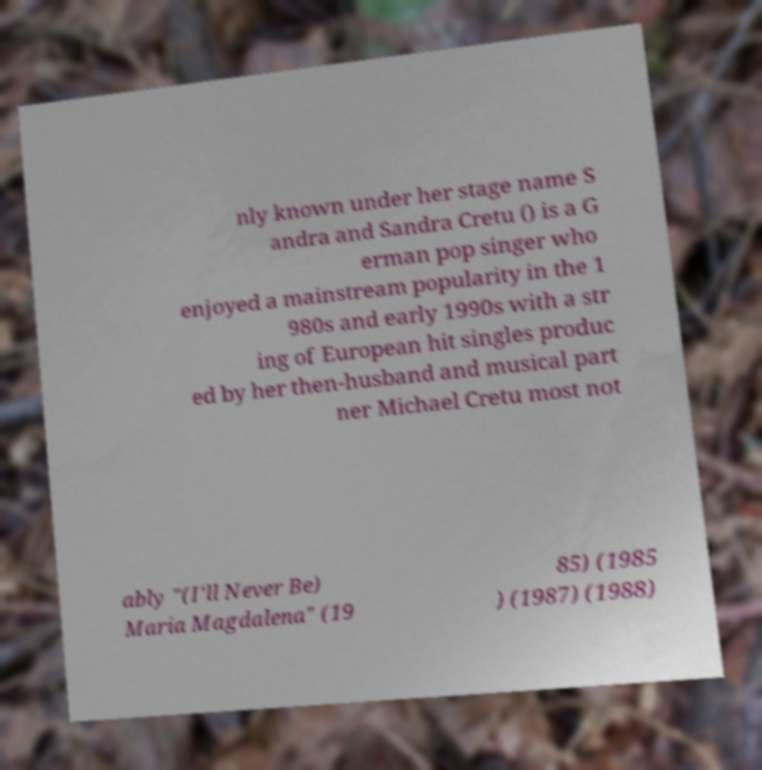Can you accurately transcribe the text from the provided image for me? nly known under her stage name S andra and Sandra Cretu () is a G erman pop singer who enjoyed a mainstream popularity in the 1 980s and early 1990s with a str ing of European hit singles produc ed by her then-husband and musical part ner Michael Cretu most not ably "(I'll Never Be) Maria Magdalena" (19 85) (1985 ) (1987) (1988) 